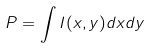<formula> <loc_0><loc_0><loc_500><loc_500>P = \int I ( x , y ) d x d y</formula> 